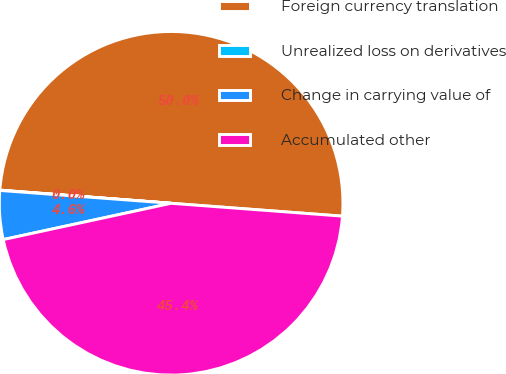<chart> <loc_0><loc_0><loc_500><loc_500><pie_chart><fcel>Foreign currency translation<fcel>Unrealized loss on derivatives<fcel>Change in carrying value of<fcel>Accumulated other<nl><fcel>49.97%<fcel>0.03%<fcel>4.58%<fcel>45.42%<nl></chart> 